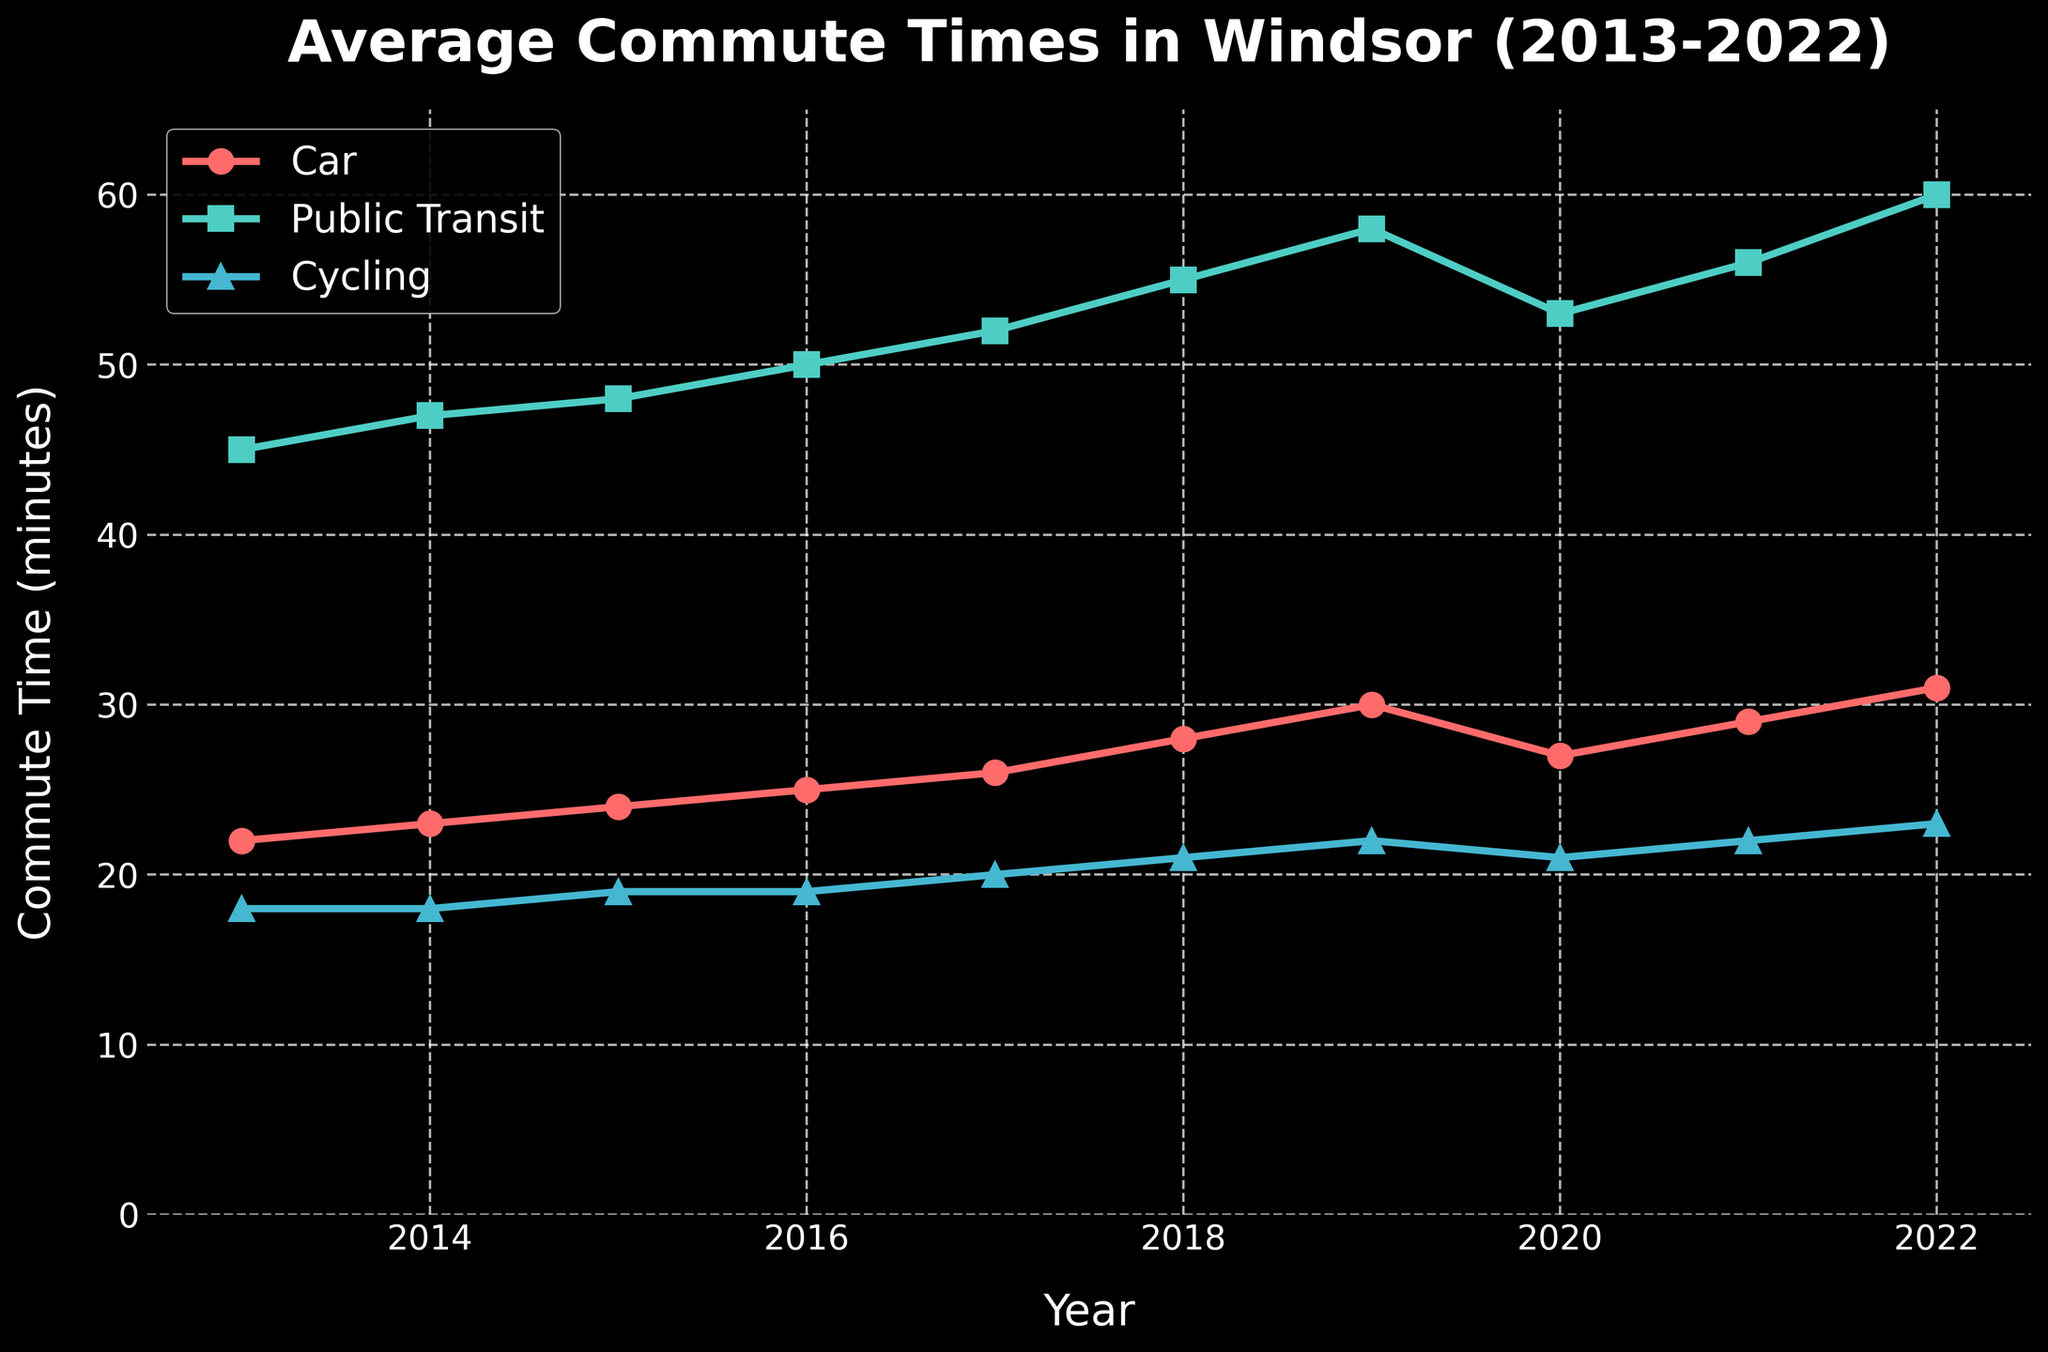What mode of transportation had the longest average commute time in 2022? The figure shows the commute times for cars, public transit, and cycling. By observing the lines, the commute time for public transit is the longest in 2022.
Answer: Public transit Which transportation mode had the least increase in average commute time from 2013 to 2022? Comparing the changes across the years, cycling increased from 18 to 23 minutes (5 minutes), cars from 22 to 31 minutes (9 minutes), and public transit from 45 to 60 minutes (15 minutes). The least increase occurred for cycling.
Answer: Cycling Has the average commute time for cars ever decreased within the period from 2013 to 2022? By examining the line for cars, the commute time decreased between 2019 and 2020 from 30 to 27 minutes.
Answer: Yes What is the difference in average commute time between public transit and cycling in 2017? The average commute time in 2017 for public transit is 52 minutes and for cycling, it is 20 minutes. The difference is 52 - 20 = 32 minutes.
Answer: 32 minutes Which year had the lowest overall average commute times combining all three modes of transportation? Calculate the average for each year by summing the commute times for all three modes and dividing by 3. The year with the smallest average value will be the answer. After calculation, 2013 has the lowest overall average.
Answer: 2013 During which year did public transit reach an average commute time of 50 minutes? Observing the public transit line, it first hits 50 minutes in 2016.
Answer: 2016 What is the sum of the average commute times for all three modes in 2022? Sum the average commute times for cars (31 minutes), public transit (60 minutes), and cycling (23 minutes). The total is 31 + 60 + 23 = 114 minutes.
Answer: 114 minutes Did any mode of transportation surpass 30 minutes of average commute time before 2019? The only mode surpassing 30 minutes is public transit, which exceeded 30 minutes in all years shown.
Answer: Yes By how many minutes did the average commute time by car increase from 2013 to 2019? In 2013, the average is 22 minutes and in 2019 it is 30 minutes. The increase is 30 - 22 = 8 minutes.
Answer: 8 minutes How did the average commute time for cycling change from 2013 to 2020? From the figure, cycling times went from 18 minutes in 2013 to 21 minutes in 2020. The change is 21 - 18 = 3 minutes.
Answer: Increased by 3 minutes 